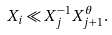Convert formula to latex. <formula><loc_0><loc_0><loc_500><loc_500>X _ { i } \ll X _ { j } ^ { - 1 } X _ { j + 1 } ^ { \theta } .</formula> 